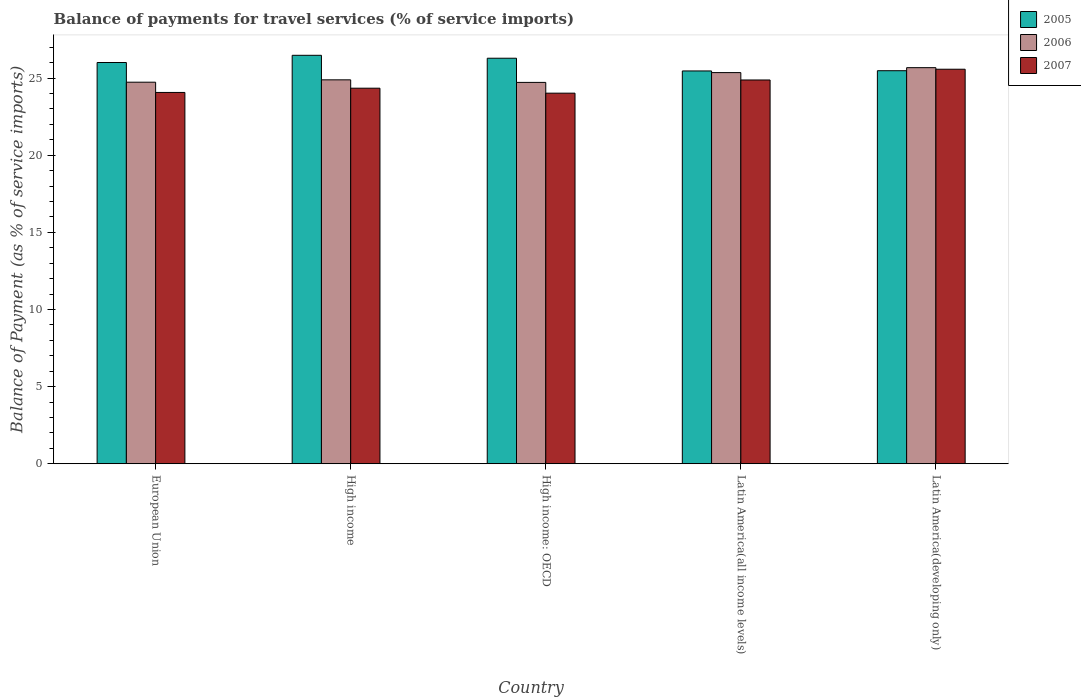How many different coloured bars are there?
Keep it short and to the point. 3. How many groups of bars are there?
Give a very brief answer. 5. How many bars are there on the 3rd tick from the left?
Ensure brevity in your answer.  3. What is the label of the 3rd group of bars from the left?
Keep it short and to the point. High income: OECD. What is the balance of payments for travel services in 2007 in Latin America(developing only)?
Your response must be concise. 25.57. Across all countries, what is the maximum balance of payments for travel services in 2005?
Provide a short and direct response. 26.48. Across all countries, what is the minimum balance of payments for travel services in 2007?
Offer a very short reply. 24.02. In which country was the balance of payments for travel services in 2007 maximum?
Keep it short and to the point. Latin America(developing only). In which country was the balance of payments for travel services in 2006 minimum?
Ensure brevity in your answer.  High income: OECD. What is the total balance of payments for travel services in 2007 in the graph?
Ensure brevity in your answer.  122.89. What is the difference between the balance of payments for travel services in 2005 in High income: OECD and that in Latin America(developing only)?
Your answer should be very brief. 0.81. What is the difference between the balance of payments for travel services in 2006 in Latin America(all income levels) and the balance of payments for travel services in 2007 in High income: OECD?
Your answer should be very brief. 1.33. What is the average balance of payments for travel services in 2005 per country?
Give a very brief answer. 25.94. What is the difference between the balance of payments for travel services of/in 2007 and balance of payments for travel services of/in 2006 in High income: OECD?
Provide a succinct answer. -0.7. In how many countries, is the balance of payments for travel services in 2005 greater than 23 %?
Your response must be concise. 5. What is the ratio of the balance of payments for travel services in 2007 in High income: OECD to that in Latin America(all income levels)?
Offer a very short reply. 0.97. What is the difference between the highest and the second highest balance of payments for travel services in 2006?
Offer a very short reply. -0.79. What is the difference between the highest and the lowest balance of payments for travel services in 2005?
Ensure brevity in your answer.  1.01. What does the 1st bar from the right in European Union represents?
Make the answer very short. 2007. Is it the case that in every country, the sum of the balance of payments for travel services in 2007 and balance of payments for travel services in 2006 is greater than the balance of payments for travel services in 2005?
Provide a short and direct response. Yes. How many bars are there?
Ensure brevity in your answer.  15. Are all the bars in the graph horizontal?
Offer a terse response. No. How many countries are there in the graph?
Your answer should be very brief. 5. What is the difference between two consecutive major ticks on the Y-axis?
Offer a terse response. 5. Are the values on the major ticks of Y-axis written in scientific E-notation?
Provide a short and direct response. No. Does the graph contain any zero values?
Your response must be concise. No. Where does the legend appear in the graph?
Offer a very short reply. Top right. What is the title of the graph?
Keep it short and to the point. Balance of payments for travel services (% of service imports). Does "1962" appear as one of the legend labels in the graph?
Your answer should be very brief. No. What is the label or title of the X-axis?
Offer a terse response. Country. What is the label or title of the Y-axis?
Your answer should be very brief. Balance of Payment (as % of service imports). What is the Balance of Payment (as % of service imports) of 2005 in European Union?
Provide a succinct answer. 26.01. What is the Balance of Payment (as % of service imports) in 2006 in European Union?
Offer a terse response. 24.73. What is the Balance of Payment (as % of service imports) in 2007 in European Union?
Your answer should be compact. 24.07. What is the Balance of Payment (as % of service imports) of 2005 in High income?
Ensure brevity in your answer.  26.48. What is the Balance of Payment (as % of service imports) of 2006 in High income?
Give a very brief answer. 24.89. What is the Balance of Payment (as % of service imports) in 2007 in High income?
Your response must be concise. 24.34. What is the Balance of Payment (as % of service imports) of 2005 in High income: OECD?
Offer a terse response. 26.29. What is the Balance of Payment (as % of service imports) in 2006 in High income: OECD?
Make the answer very short. 24.72. What is the Balance of Payment (as % of service imports) in 2007 in High income: OECD?
Offer a terse response. 24.02. What is the Balance of Payment (as % of service imports) of 2005 in Latin America(all income levels)?
Ensure brevity in your answer.  25.46. What is the Balance of Payment (as % of service imports) of 2006 in Latin America(all income levels)?
Offer a very short reply. 25.36. What is the Balance of Payment (as % of service imports) of 2007 in Latin America(all income levels)?
Give a very brief answer. 24.88. What is the Balance of Payment (as % of service imports) of 2005 in Latin America(developing only)?
Your answer should be compact. 25.48. What is the Balance of Payment (as % of service imports) in 2006 in Latin America(developing only)?
Your answer should be very brief. 25.68. What is the Balance of Payment (as % of service imports) in 2007 in Latin America(developing only)?
Offer a terse response. 25.57. Across all countries, what is the maximum Balance of Payment (as % of service imports) of 2005?
Provide a succinct answer. 26.48. Across all countries, what is the maximum Balance of Payment (as % of service imports) in 2006?
Ensure brevity in your answer.  25.68. Across all countries, what is the maximum Balance of Payment (as % of service imports) in 2007?
Ensure brevity in your answer.  25.57. Across all countries, what is the minimum Balance of Payment (as % of service imports) in 2005?
Provide a succinct answer. 25.46. Across all countries, what is the minimum Balance of Payment (as % of service imports) of 2006?
Provide a short and direct response. 24.72. Across all countries, what is the minimum Balance of Payment (as % of service imports) in 2007?
Offer a very short reply. 24.02. What is the total Balance of Payment (as % of service imports) of 2005 in the graph?
Provide a succinct answer. 129.71. What is the total Balance of Payment (as % of service imports) of 2006 in the graph?
Your answer should be compact. 125.37. What is the total Balance of Payment (as % of service imports) in 2007 in the graph?
Offer a terse response. 122.89. What is the difference between the Balance of Payment (as % of service imports) in 2005 in European Union and that in High income?
Your answer should be compact. -0.47. What is the difference between the Balance of Payment (as % of service imports) of 2006 in European Union and that in High income?
Give a very brief answer. -0.15. What is the difference between the Balance of Payment (as % of service imports) in 2007 in European Union and that in High income?
Offer a terse response. -0.28. What is the difference between the Balance of Payment (as % of service imports) in 2005 in European Union and that in High income: OECD?
Ensure brevity in your answer.  -0.28. What is the difference between the Balance of Payment (as % of service imports) of 2006 in European Union and that in High income: OECD?
Your answer should be very brief. 0.01. What is the difference between the Balance of Payment (as % of service imports) in 2007 in European Union and that in High income: OECD?
Your answer should be compact. 0.05. What is the difference between the Balance of Payment (as % of service imports) of 2005 in European Union and that in Latin America(all income levels)?
Provide a short and direct response. 0.55. What is the difference between the Balance of Payment (as % of service imports) of 2006 in European Union and that in Latin America(all income levels)?
Give a very brief answer. -0.62. What is the difference between the Balance of Payment (as % of service imports) in 2007 in European Union and that in Latin America(all income levels)?
Ensure brevity in your answer.  -0.81. What is the difference between the Balance of Payment (as % of service imports) of 2005 in European Union and that in Latin America(developing only)?
Your answer should be compact. 0.53. What is the difference between the Balance of Payment (as % of service imports) in 2006 in European Union and that in Latin America(developing only)?
Keep it short and to the point. -0.94. What is the difference between the Balance of Payment (as % of service imports) in 2007 in European Union and that in Latin America(developing only)?
Offer a very short reply. -1.5. What is the difference between the Balance of Payment (as % of service imports) of 2005 in High income and that in High income: OECD?
Your response must be concise. 0.19. What is the difference between the Balance of Payment (as % of service imports) in 2006 in High income and that in High income: OECD?
Your answer should be very brief. 0.17. What is the difference between the Balance of Payment (as % of service imports) in 2007 in High income and that in High income: OECD?
Your response must be concise. 0.32. What is the difference between the Balance of Payment (as % of service imports) in 2005 in High income and that in Latin America(all income levels)?
Your response must be concise. 1.01. What is the difference between the Balance of Payment (as % of service imports) in 2006 in High income and that in Latin America(all income levels)?
Ensure brevity in your answer.  -0.47. What is the difference between the Balance of Payment (as % of service imports) in 2007 in High income and that in Latin America(all income levels)?
Provide a succinct answer. -0.53. What is the difference between the Balance of Payment (as % of service imports) of 2006 in High income and that in Latin America(developing only)?
Your response must be concise. -0.79. What is the difference between the Balance of Payment (as % of service imports) of 2007 in High income and that in Latin America(developing only)?
Provide a short and direct response. -1.23. What is the difference between the Balance of Payment (as % of service imports) in 2005 in High income: OECD and that in Latin America(all income levels)?
Your answer should be compact. 0.82. What is the difference between the Balance of Payment (as % of service imports) of 2006 in High income: OECD and that in Latin America(all income levels)?
Provide a succinct answer. -0.64. What is the difference between the Balance of Payment (as % of service imports) of 2007 in High income: OECD and that in Latin America(all income levels)?
Offer a terse response. -0.85. What is the difference between the Balance of Payment (as % of service imports) in 2005 in High income: OECD and that in Latin America(developing only)?
Make the answer very short. 0.81. What is the difference between the Balance of Payment (as % of service imports) of 2006 in High income: OECD and that in Latin America(developing only)?
Give a very brief answer. -0.95. What is the difference between the Balance of Payment (as % of service imports) in 2007 in High income: OECD and that in Latin America(developing only)?
Ensure brevity in your answer.  -1.55. What is the difference between the Balance of Payment (as % of service imports) in 2005 in Latin America(all income levels) and that in Latin America(developing only)?
Ensure brevity in your answer.  -0.02. What is the difference between the Balance of Payment (as % of service imports) of 2006 in Latin America(all income levels) and that in Latin America(developing only)?
Ensure brevity in your answer.  -0.32. What is the difference between the Balance of Payment (as % of service imports) in 2007 in Latin America(all income levels) and that in Latin America(developing only)?
Your response must be concise. -0.7. What is the difference between the Balance of Payment (as % of service imports) in 2005 in European Union and the Balance of Payment (as % of service imports) in 2006 in High income?
Your response must be concise. 1.12. What is the difference between the Balance of Payment (as % of service imports) in 2005 in European Union and the Balance of Payment (as % of service imports) in 2007 in High income?
Ensure brevity in your answer.  1.67. What is the difference between the Balance of Payment (as % of service imports) in 2006 in European Union and the Balance of Payment (as % of service imports) in 2007 in High income?
Keep it short and to the point. 0.39. What is the difference between the Balance of Payment (as % of service imports) in 2005 in European Union and the Balance of Payment (as % of service imports) in 2006 in High income: OECD?
Give a very brief answer. 1.29. What is the difference between the Balance of Payment (as % of service imports) of 2005 in European Union and the Balance of Payment (as % of service imports) of 2007 in High income: OECD?
Give a very brief answer. 1.99. What is the difference between the Balance of Payment (as % of service imports) in 2006 in European Union and the Balance of Payment (as % of service imports) in 2007 in High income: OECD?
Your answer should be compact. 0.71. What is the difference between the Balance of Payment (as % of service imports) of 2005 in European Union and the Balance of Payment (as % of service imports) of 2006 in Latin America(all income levels)?
Provide a succinct answer. 0.65. What is the difference between the Balance of Payment (as % of service imports) in 2005 in European Union and the Balance of Payment (as % of service imports) in 2007 in Latin America(all income levels)?
Offer a very short reply. 1.13. What is the difference between the Balance of Payment (as % of service imports) in 2006 in European Union and the Balance of Payment (as % of service imports) in 2007 in Latin America(all income levels)?
Keep it short and to the point. -0.14. What is the difference between the Balance of Payment (as % of service imports) of 2005 in European Union and the Balance of Payment (as % of service imports) of 2006 in Latin America(developing only)?
Your response must be concise. 0.33. What is the difference between the Balance of Payment (as % of service imports) in 2005 in European Union and the Balance of Payment (as % of service imports) in 2007 in Latin America(developing only)?
Your response must be concise. 0.44. What is the difference between the Balance of Payment (as % of service imports) of 2006 in European Union and the Balance of Payment (as % of service imports) of 2007 in Latin America(developing only)?
Offer a terse response. -0.84. What is the difference between the Balance of Payment (as % of service imports) in 2005 in High income and the Balance of Payment (as % of service imports) in 2006 in High income: OECD?
Provide a short and direct response. 1.76. What is the difference between the Balance of Payment (as % of service imports) in 2005 in High income and the Balance of Payment (as % of service imports) in 2007 in High income: OECD?
Keep it short and to the point. 2.45. What is the difference between the Balance of Payment (as % of service imports) in 2006 in High income and the Balance of Payment (as % of service imports) in 2007 in High income: OECD?
Give a very brief answer. 0.86. What is the difference between the Balance of Payment (as % of service imports) in 2005 in High income and the Balance of Payment (as % of service imports) in 2006 in Latin America(all income levels)?
Your answer should be compact. 1.12. What is the difference between the Balance of Payment (as % of service imports) in 2005 in High income and the Balance of Payment (as % of service imports) in 2007 in Latin America(all income levels)?
Give a very brief answer. 1.6. What is the difference between the Balance of Payment (as % of service imports) of 2006 in High income and the Balance of Payment (as % of service imports) of 2007 in Latin America(all income levels)?
Offer a terse response. 0.01. What is the difference between the Balance of Payment (as % of service imports) in 2005 in High income and the Balance of Payment (as % of service imports) in 2006 in Latin America(developing only)?
Your answer should be very brief. 0.8. What is the difference between the Balance of Payment (as % of service imports) in 2005 in High income and the Balance of Payment (as % of service imports) in 2007 in Latin America(developing only)?
Provide a short and direct response. 0.9. What is the difference between the Balance of Payment (as % of service imports) in 2006 in High income and the Balance of Payment (as % of service imports) in 2007 in Latin America(developing only)?
Ensure brevity in your answer.  -0.69. What is the difference between the Balance of Payment (as % of service imports) of 2005 in High income: OECD and the Balance of Payment (as % of service imports) of 2006 in Latin America(all income levels)?
Make the answer very short. 0.93. What is the difference between the Balance of Payment (as % of service imports) of 2005 in High income: OECD and the Balance of Payment (as % of service imports) of 2007 in Latin America(all income levels)?
Offer a terse response. 1.41. What is the difference between the Balance of Payment (as % of service imports) in 2006 in High income: OECD and the Balance of Payment (as % of service imports) in 2007 in Latin America(all income levels)?
Offer a very short reply. -0.16. What is the difference between the Balance of Payment (as % of service imports) of 2005 in High income: OECD and the Balance of Payment (as % of service imports) of 2006 in Latin America(developing only)?
Give a very brief answer. 0.61. What is the difference between the Balance of Payment (as % of service imports) in 2005 in High income: OECD and the Balance of Payment (as % of service imports) in 2007 in Latin America(developing only)?
Make the answer very short. 0.71. What is the difference between the Balance of Payment (as % of service imports) in 2006 in High income: OECD and the Balance of Payment (as % of service imports) in 2007 in Latin America(developing only)?
Your answer should be very brief. -0.85. What is the difference between the Balance of Payment (as % of service imports) in 2005 in Latin America(all income levels) and the Balance of Payment (as % of service imports) in 2006 in Latin America(developing only)?
Offer a very short reply. -0.21. What is the difference between the Balance of Payment (as % of service imports) in 2005 in Latin America(all income levels) and the Balance of Payment (as % of service imports) in 2007 in Latin America(developing only)?
Your answer should be very brief. -0.11. What is the difference between the Balance of Payment (as % of service imports) of 2006 in Latin America(all income levels) and the Balance of Payment (as % of service imports) of 2007 in Latin America(developing only)?
Your response must be concise. -0.22. What is the average Balance of Payment (as % of service imports) in 2005 per country?
Make the answer very short. 25.94. What is the average Balance of Payment (as % of service imports) in 2006 per country?
Ensure brevity in your answer.  25.07. What is the average Balance of Payment (as % of service imports) of 2007 per country?
Make the answer very short. 24.58. What is the difference between the Balance of Payment (as % of service imports) in 2005 and Balance of Payment (as % of service imports) in 2006 in European Union?
Your answer should be very brief. 1.28. What is the difference between the Balance of Payment (as % of service imports) of 2005 and Balance of Payment (as % of service imports) of 2007 in European Union?
Offer a terse response. 1.94. What is the difference between the Balance of Payment (as % of service imports) of 2006 and Balance of Payment (as % of service imports) of 2007 in European Union?
Your response must be concise. 0.66. What is the difference between the Balance of Payment (as % of service imports) in 2005 and Balance of Payment (as % of service imports) in 2006 in High income?
Provide a succinct answer. 1.59. What is the difference between the Balance of Payment (as % of service imports) of 2005 and Balance of Payment (as % of service imports) of 2007 in High income?
Give a very brief answer. 2.13. What is the difference between the Balance of Payment (as % of service imports) of 2006 and Balance of Payment (as % of service imports) of 2007 in High income?
Make the answer very short. 0.54. What is the difference between the Balance of Payment (as % of service imports) of 2005 and Balance of Payment (as % of service imports) of 2006 in High income: OECD?
Keep it short and to the point. 1.57. What is the difference between the Balance of Payment (as % of service imports) of 2005 and Balance of Payment (as % of service imports) of 2007 in High income: OECD?
Your answer should be compact. 2.26. What is the difference between the Balance of Payment (as % of service imports) in 2006 and Balance of Payment (as % of service imports) in 2007 in High income: OECD?
Keep it short and to the point. 0.7. What is the difference between the Balance of Payment (as % of service imports) of 2005 and Balance of Payment (as % of service imports) of 2006 in Latin America(all income levels)?
Your answer should be very brief. 0.11. What is the difference between the Balance of Payment (as % of service imports) in 2005 and Balance of Payment (as % of service imports) in 2007 in Latin America(all income levels)?
Your answer should be compact. 0.59. What is the difference between the Balance of Payment (as % of service imports) of 2006 and Balance of Payment (as % of service imports) of 2007 in Latin America(all income levels)?
Keep it short and to the point. 0.48. What is the difference between the Balance of Payment (as % of service imports) in 2005 and Balance of Payment (as % of service imports) in 2006 in Latin America(developing only)?
Your answer should be very brief. -0.2. What is the difference between the Balance of Payment (as % of service imports) of 2005 and Balance of Payment (as % of service imports) of 2007 in Latin America(developing only)?
Make the answer very short. -0.1. What is the difference between the Balance of Payment (as % of service imports) of 2006 and Balance of Payment (as % of service imports) of 2007 in Latin America(developing only)?
Ensure brevity in your answer.  0.1. What is the ratio of the Balance of Payment (as % of service imports) in 2005 in European Union to that in High income?
Your answer should be compact. 0.98. What is the ratio of the Balance of Payment (as % of service imports) in 2007 in European Union to that in High income?
Make the answer very short. 0.99. What is the ratio of the Balance of Payment (as % of service imports) in 2007 in European Union to that in High income: OECD?
Offer a very short reply. 1. What is the ratio of the Balance of Payment (as % of service imports) in 2005 in European Union to that in Latin America(all income levels)?
Keep it short and to the point. 1.02. What is the ratio of the Balance of Payment (as % of service imports) of 2006 in European Union to that in Latin America(all income levels)?
Make the answer very short. 0.98. What is the ratio of the Balance of Payment (as % of service imports) of 2007 in European Union to that in Latin America(all income levels)?
Provide a short and direct response. 0.97. What is the ratio of the Balance of Payment (as % of service imports) in 2005 in European Union to that in Latin America(developing only)?
Offer a terse response. 1.02. What is the ratio of the Balance of Payment (as % of service imports) in 2006 in European Union to that in Latin America(developing only)?
Make the answer very short. 0.96. What is the ratio of the Balance of Payment (as % of service imports) in 2007 in European Union to that in Latin America(developing only)?
Make the answer very short. 0.94. What is the ratio of the Balance of Payment (as % of service imports) in 2005 in High income to that in High income: OECD?
Give a very brief answer. 1.01. What is the ratio of the Balance of Payment (as % of service imports) in 2006 in High income to that in High income: OECD?
Give a very brief answer. 1.01. What is the ratio of the Balance of Payment (as % of service imports) of 2007 in High income to that in High income: OECD?
Offer a very short reply. 1.01. What is the ratio of the Balance of Payment (as % of service imports) of 2005 in High income to that in Latin America(all income levels)?
Ensure brevity in your answer.  1.04. What is the ratio of the Balance of Payment (as % of service imports) of 2006 in High income to that in Latin America(all income levels)?
Make the answer very short. 0.98. What is the ratio of the Balance of Payment (as % of service imports) of 2007 in High income to that in Latin America(all income levels)?
Your answer should be very brief. 0.98. What is the ratio of the Balance of Payment (as % of service imports) in 2005 in High income to that in Latin America(developing only)?
Your answer should be very brief. 1.04. What is the ratio of the Balance of Payment (as % of service imports) of 2006 in High income to that in Latin America(developing only)?
Make the answer very short. 0.97. What is the ratio of the Balance of Payment (as % of service imports) in 2007 in High income to that in Latin America(developing only)?
Give a very brief answer. 0.95. What is the ratio of the Balance of Payment (as % of service imports) in 2005 in High income: OECD to that in Latin America(all income levels)?
Your response must be concise. 1.03. What is the ratio of the Balance of Payment (as % of service imports) of 2007 in High income: OECD to that in Latin America(all income levels)?
Your answer should be compact. 0.97. What is the ratio of the Balance of Payment (as % of service imports) of 2005 in High income: OECD to that in Latin America(developing only)?
Ensure brevity in your answer.  1.03. What is the ratio of the Balance of Payment (as % of service imports) of 2006 in High income: OECD to that in Latin America(developing only)?
Your answer should be compact. 0.96. What is the ratio of the Balance of Payment (as % of service imports) of 2007 in High income: OECD to that in Latin America(developing only)?
Provide a short and direct response. 0.94. What is the ratio of the Balance of Payment (as % of service imports) of 2006 in Latin America(all income levels) to that in Latin America(developing only)?
Make the answer very short. 0.99. What is the ratio of the Balance of Payment (as % of service imports) of 2007 in Latin America(all income levels) to that in Latin America(developing only)?
Your response must be concise. 0.97. What is the difference between the highest and the second highest Balance of Payment (as % of service imports) of 2005?
Offer a very short reply. 0.19. What is the difference between the highest and the second highest Balance of Payment (as % of service imports) of 2006?
Your answer should be very brief. 0.32. What is the difference between the highest and the second highest Balance of Payment (as % of service imports) of 2007?
Your answer should be compact. 0.7. What is the difference between the highest and the lowest Balance of Payment (as % of service imports) in 2005?
Offer a terse response. 1.01. What is the difference between the highest and the lowest Balance of Payment (as % of service imports) of 2006?
Make the answer very short. 0.95. What is the difference between the highest and the lowest Balance of Payment (as % of service imports) in 2007?
Offer a terse response. 1.55. 